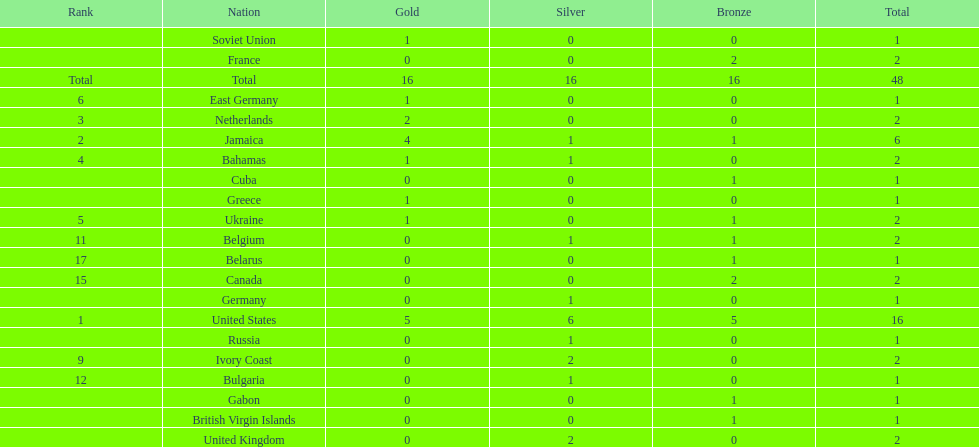What country won more gold medals than any other? United States. 